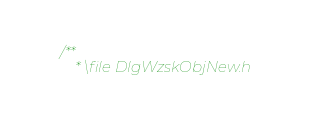Convert code to text. <code><loc_0><loc_0><loc_500><loc_500><_C_>/**
	* \file DlgWzskObjNew.h</code> 